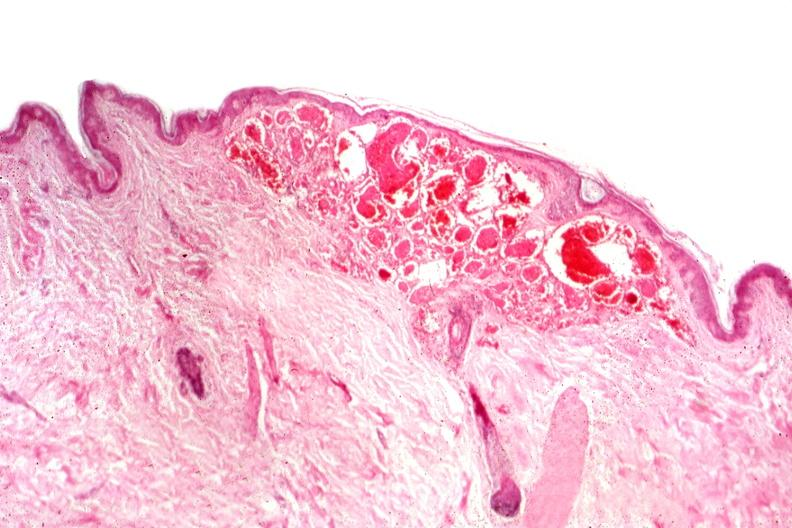s mucicarmine present?
Answer the question using a single word or phrase. No 